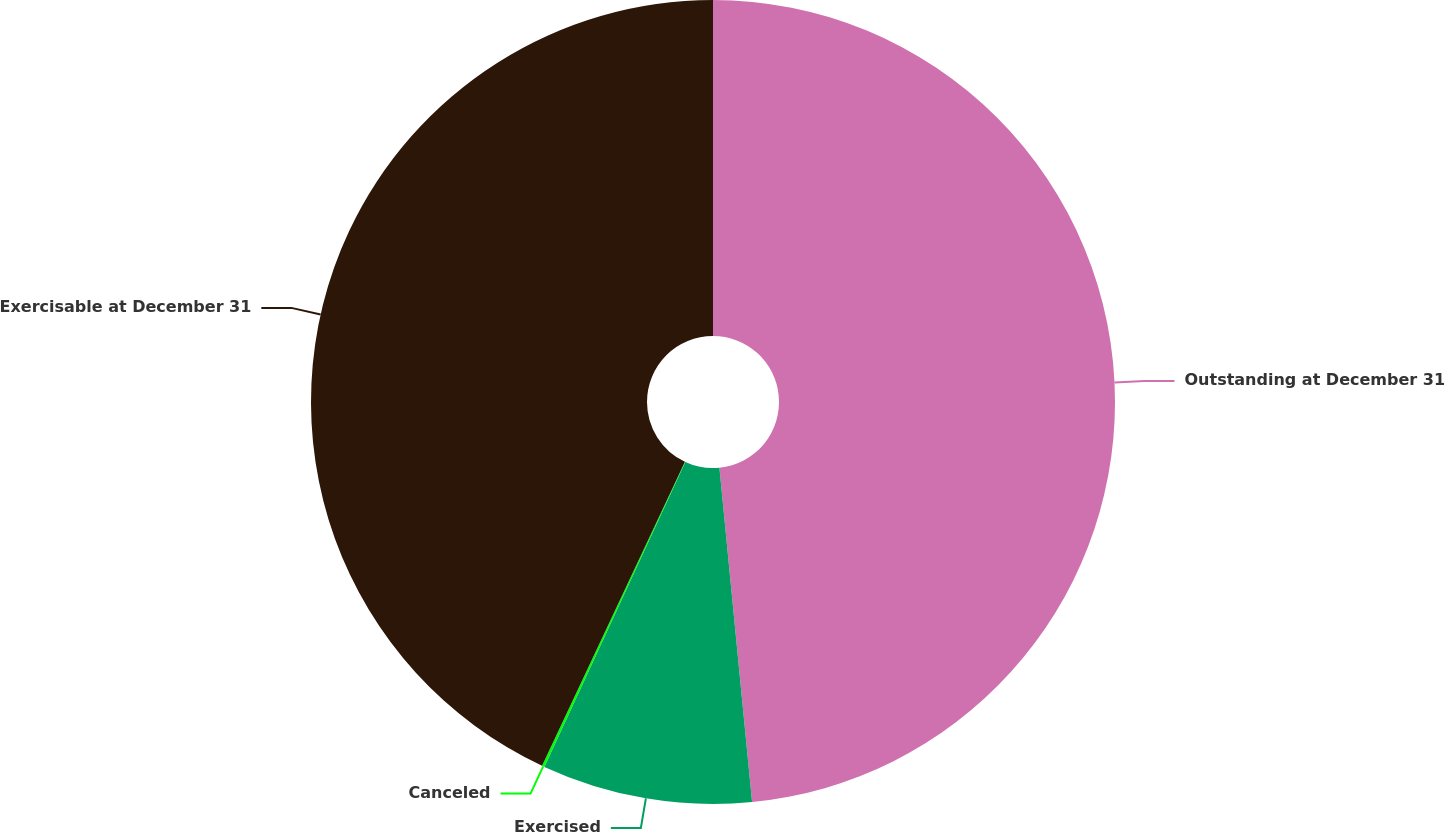Convert chart. <chart><loc_0><loc_0><loc_500><loc_500><pie_chart><fcel>Outstanding at December 31<fcel>Exercised<fcel>Canceled<fcel>Exercisable at December 31<nl><fcel>48.45%<fcel>8.44%<fcel>0.1%<fcel>43.01%<nl></chart> 